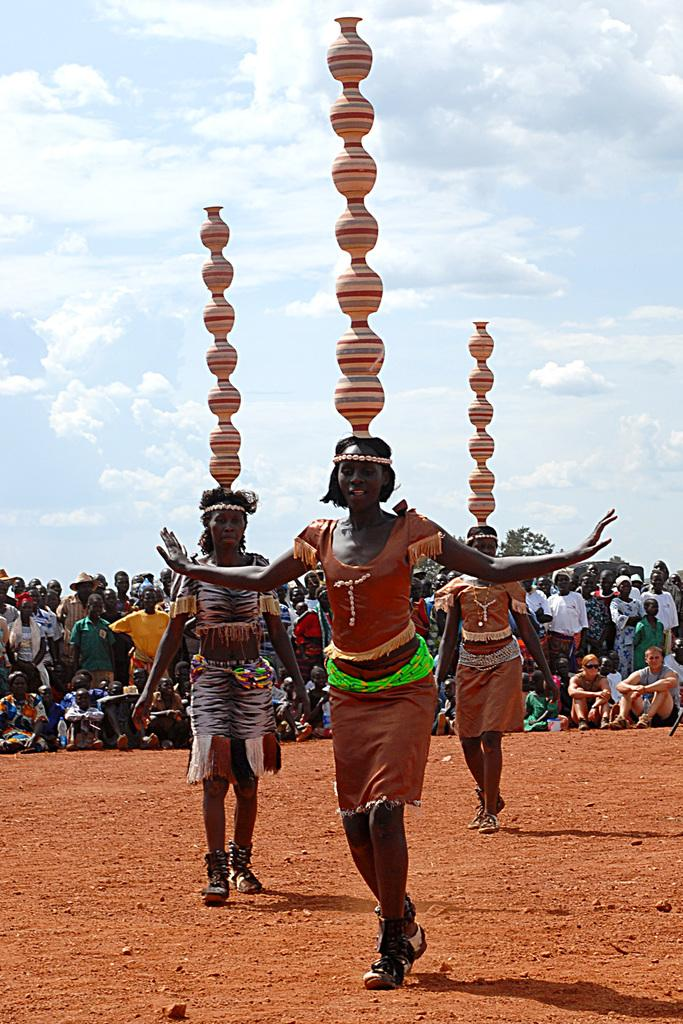What are the persons in the center of the image doing? The persons in the center of the image are standing and performing stunts. What are the persons in the background of the image doing? The persons in the background of the image are standing and sitting. What can be seen in the background of the image besides the persons? There is a tree visible in the background of the image. How would you describe the weather based on the sky in the image? The sky is cloudy in the image, which suggests a potentially overcast or rainy day. Can you tell me how many cards are being held by the persons in the image? There are no cards visible in the image; the persons are performing stunts and standing or sitting. What type of planes can be seen flying in the image? There are no planes present in the image; it features persons performing stunts and standing or sitting. 